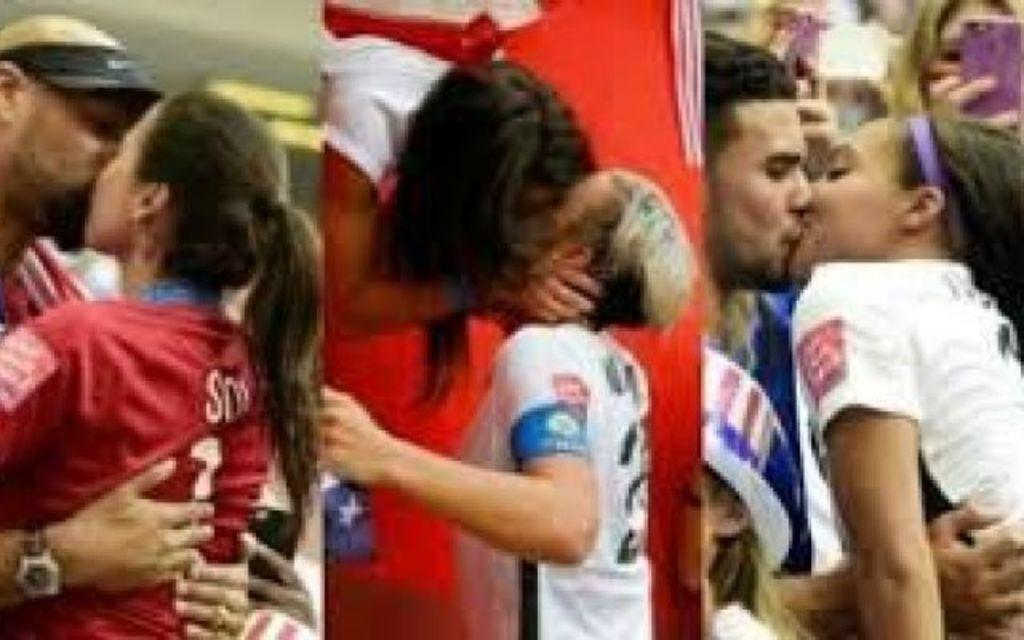What are the people in the image doing? The people in the image are kissing. Can you describe any objects or items held by the people in the image? Yes, there is a person holding a mobile in the image. What type of reward is being given to the person with the eyes in the image? There is no mention of a reward or eyes in the image; it only shows people kissing and a person holding a mobile. 